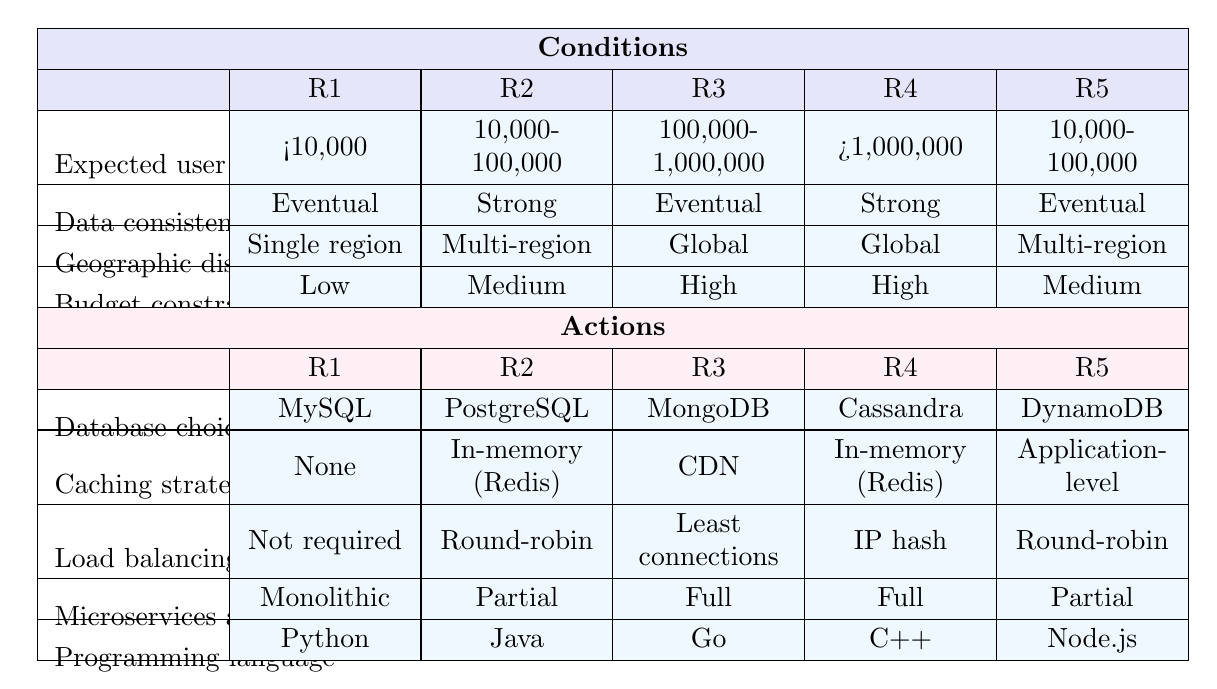What database choice is recommended for a budget constraint of high? Looking at the action options under the table, we find that when the budget constraint is high, the recommended database choices are MongoDB and Cassandra. These are the only two options available for high budget conditions.
Answer: MongoDB and Cassandra Is a caching strategy required when the expected user load is less than 10,000? According to the table, for an expected user load of less than 10,000, the caching strategy is listed as none. Therefore, it is not required.
Answer: No How many different programming languages are suggested for a multi-region distribution with strong data consistency requirements? The relevant row shows that the programming languages suggested for multi-region distribution and strong data consistency are Java (for the second rule) and Node.js (for the last rule), which totals two different suggested programming languages.
Answer: 2 Is it true that the load balancing method for global distribution with eventual data consistency is least connections? Upon examining the options, for the global distribution with eventual consistency, the load balancing method suggested is least connections, which is not the case. The answer is therefore false.
Answer: False When the expected user load is between 10,000 and 100,000, what is the programming language choice? The table specifies that for a load between 10,000 and 100,000, the recommended programming language is Java for strong consistency and Node.js for eventual consistency, hence two potential choices exist. However, the context of the rule needs clarification to focus on strong consistency requirements for comprehensive guidance.
Answer: Java and Node.js 